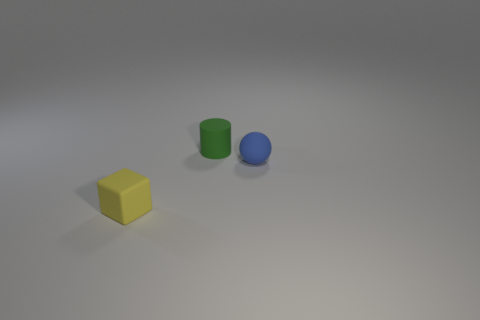Add 2 tiny brown things. How many objects exist? 5 Subtract all cylinders. How many objects are left? 2 Subtract all rubber objects. Subtract all small gray rubber blocks. How many objects are left? 0 Add 1 yellow objects. How many yellow objects are left? 2 Add 1 tiny matte blocks. How many tiny matte blocks exist? 2 Subtract 0 blue cylinders. How many objects are left? 3 